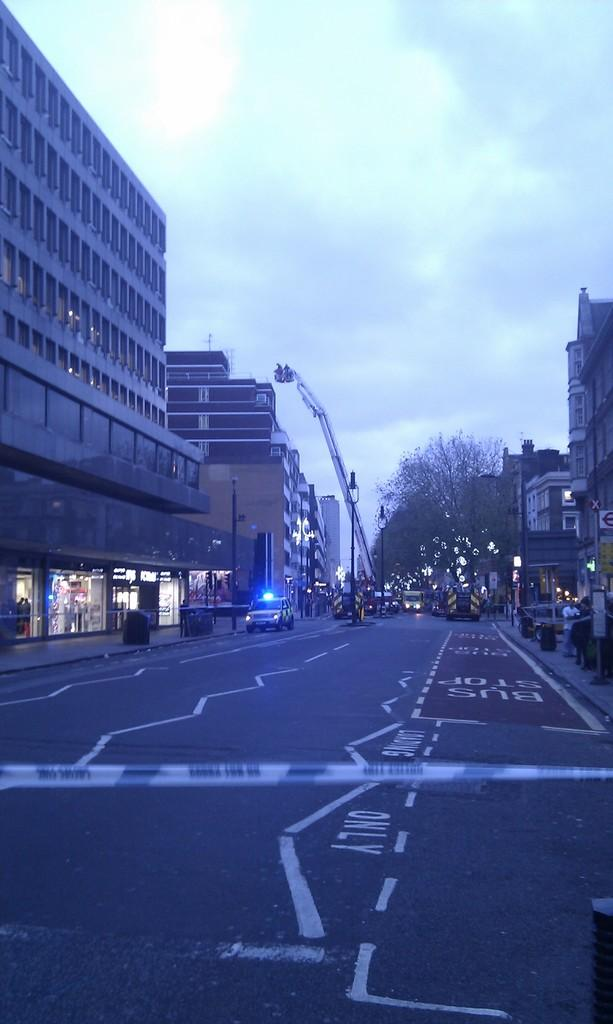What can be seen in the background of the image? There are buildings, trees, and lights in the background of the image. What types of objects are present in the image? There are vehicles and persons in the image. What is the condition of the sky in the image? The sky is cloudy in the image. Can you tell me the route the girl takes to trade her goods in the image? There is no girl or trade activity present in the image. What type of trade is being conducted by the persons in the image? There is no trade activity depicted in the image; the persons are simply present in the scene. 